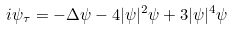Convert formula to latex. <formula><loc_0><loc_0><loc_500><loc_500>i { \psi _ { \tau } } = - \Delta \psi - 4 | \psi | ^ { 2 } \/ \psi + 3 | \psi | ^ { 4 } \/ \psi</formula> 